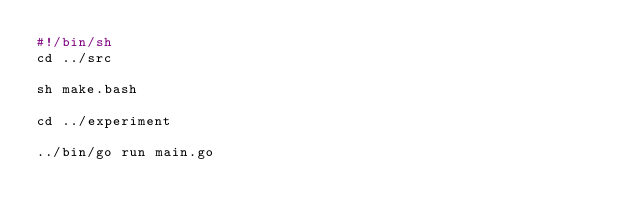Convert code to text. <code><loc_0><loc_0><loc_500><loc_500><_Bash_>#!/bin/sh
cd ../src

sh make.bash

cd ../experiment

../bin/go run main.go</code> 